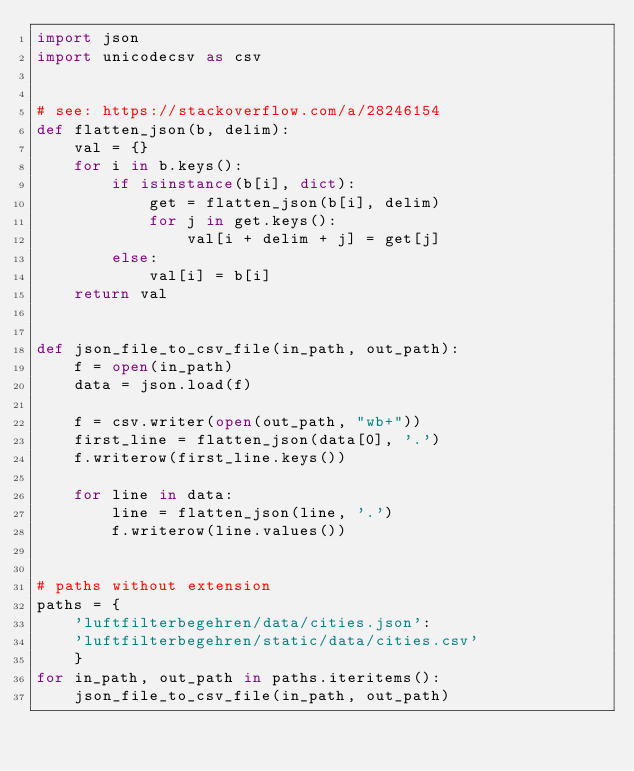<code> <loc_0><loc_0><loc_500><loc_500><_Python_>import json
import unicodecsv as csv


# see: https://stackoverflow.com/a/28246154
def flatten_json(b, delim):
    val = {}
    for i in b.keys():
        if isinstance(b[i], dict):
            get = flatten_json(b[i], delim)
            for j in get.keys():
                val[i + delim + j] = get[j]
        else:
            val[i] = b[i]
    return val


def json_file_to_csv_file(in_path, out_path):
    f = open(in_path)
    data = json.load(f)

    f = csv.writer(open(out_path, "wb+"))
    first_line = flatten_json(data[0], '.')
    f.writerow(first_line.keys())

    for line in data:
        line = flatten_json(line, '.')
        f.writerow(line.values())


# paths without extension
paths = {
    'luftfilterbegehren/data/cities.json':
    'luftfilterbegehren/static/data/cities.csv'
    }
for in_path, out_path in paths.iteritems():
    json_file_to_csv_file(in_path, out_path)
</code> 